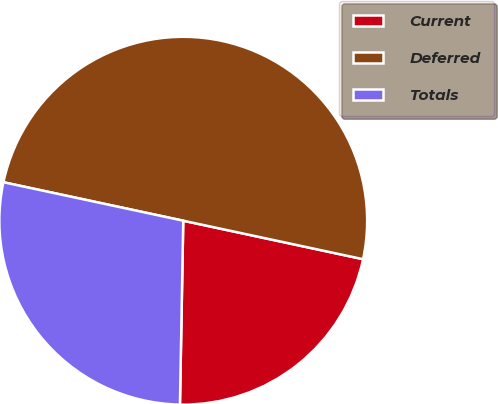Convert chart. <chart><loc_0><loc_0><loc_500><loc_500><pie_chart><fcel>Current<fcel>Deferred<fcel>Totals<nl><fcel>21.93%<fcel>50.0%<fcel>28.07%<nl></chart> 